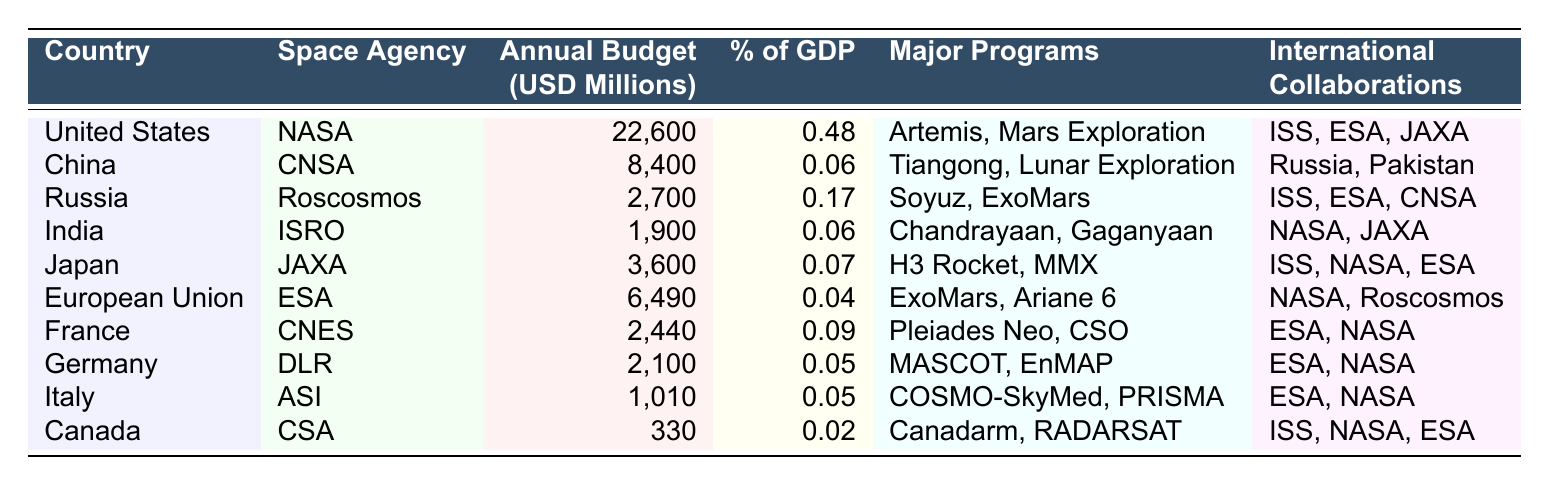What is the highest annual budget for a space agency? The table lists NASA with an annual budget of 22,600 million USD, which is the highest among all space agencies in the table.
Answer: 22,600 million USD Which country has the lowest percentage of GDP allocated to its space agency? Canada has 0.02% of its GDP allocated to its space agency (CSA), which is the lowest percentage in the table.
Answer: 0.02% What are the major programs of the European Space Agency? The table states that the major programs of the ESA include ExoMars and Ariane 6.
Answer: ExoMars and Ariane 6 Which country collaborates with both NASA and ESA? The countries that collaborate with both NASA and ESA are Russia (Roscosmos) and Japan (JAXA) according to the table.
Answer: Russia and Japan What is the total annual budget for the top three space agencies? The top three budgets are NASA (22,600 million), CNSA (8,400 million), and Roscosmos (2,700 million). When summed: 22,600 + 8,400 + 2,700 = 33,700 million USD.
Answer: 33,700 million USD Is India collaborating with China on any space programs? Based on the table, India (ISRO) collaborates with NASA and JAXA, but there is no mention of collaboration with China (CNSA). So, the answer is no.
Answer: No How many space agencies have a budget of over 5,000 million USD? The table shows that only NASA (22,600 million) and CNSA (8,400 million) have budgets over 5,000 million USD, totaling two agencies with such budgets.
Answer: 2 What is the average budget of the space agencies listed in the table? The budgets listed are: 22,600, 8,400, 2,700, 1,900, 3,600, 6,490, 2,440, 2,100, 1,010, and 330 million. Summing these gives 48,670 million, and dividing by the number of agencies (10) results in an average budget of 4,867 million USD.
Answer: 4,867 million USD Which country has allocated the highest percentage of GDP to its space agency? The United States has allocated 0.48% of its GDP to NASA, which is the highest percentage among all the countries in the table.
Answer: 0.48% Which space agency has the name 'CNSA'? According to the table, CNSA refers to the China National Space Administration, which is the space agency of China.
Answer: China National Space Administration 